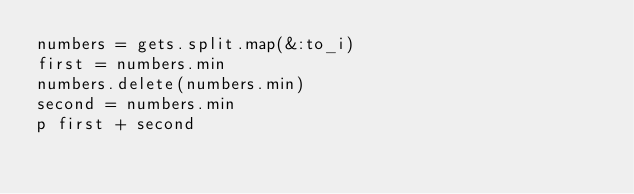Convert code to text. <code><loc_0><loc_0><loc_500><loc_500><_Ruby_>numbers = gets.split.map(&:to_i)
first = numbers.min
numbers.delete(numbers.min)
second = numbers.min
p first + second</code> 